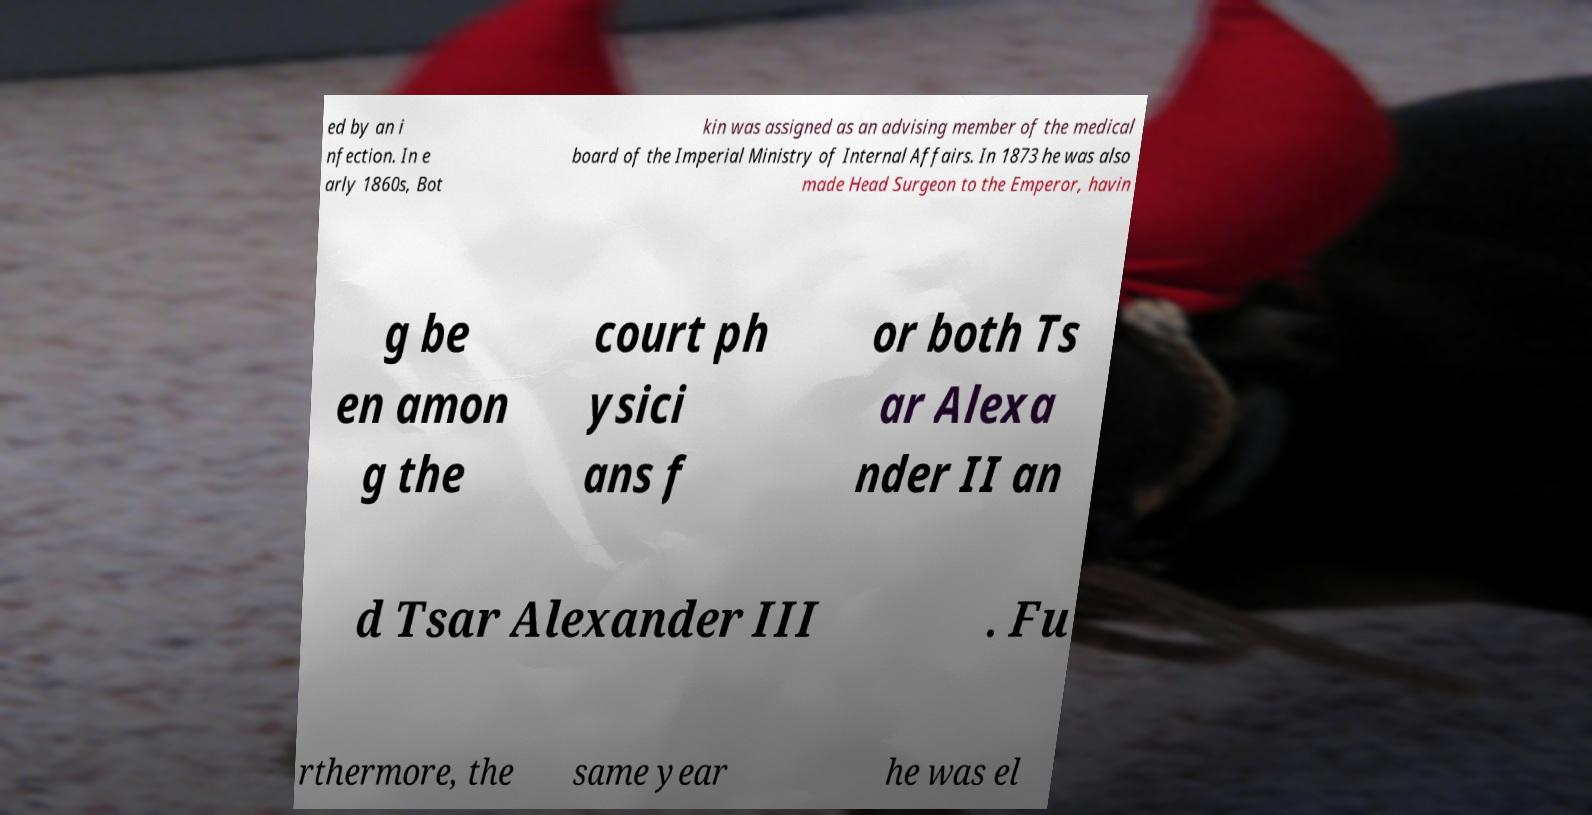Please read and relay the text visible in this image. What does it say? ed by an i nfection. In e arly 1860s, Bot kin was assigned as an advising member of the medical board of the Imperial Ministry of Internal Affairs. In 1873 he was also made Head Surgeon to the Emperor, havin g be en amon g the court ph ysici ans f or both Ts ar Alexa nder II an d Tsar Alexander III . Fu rthermore, the same year he was el 